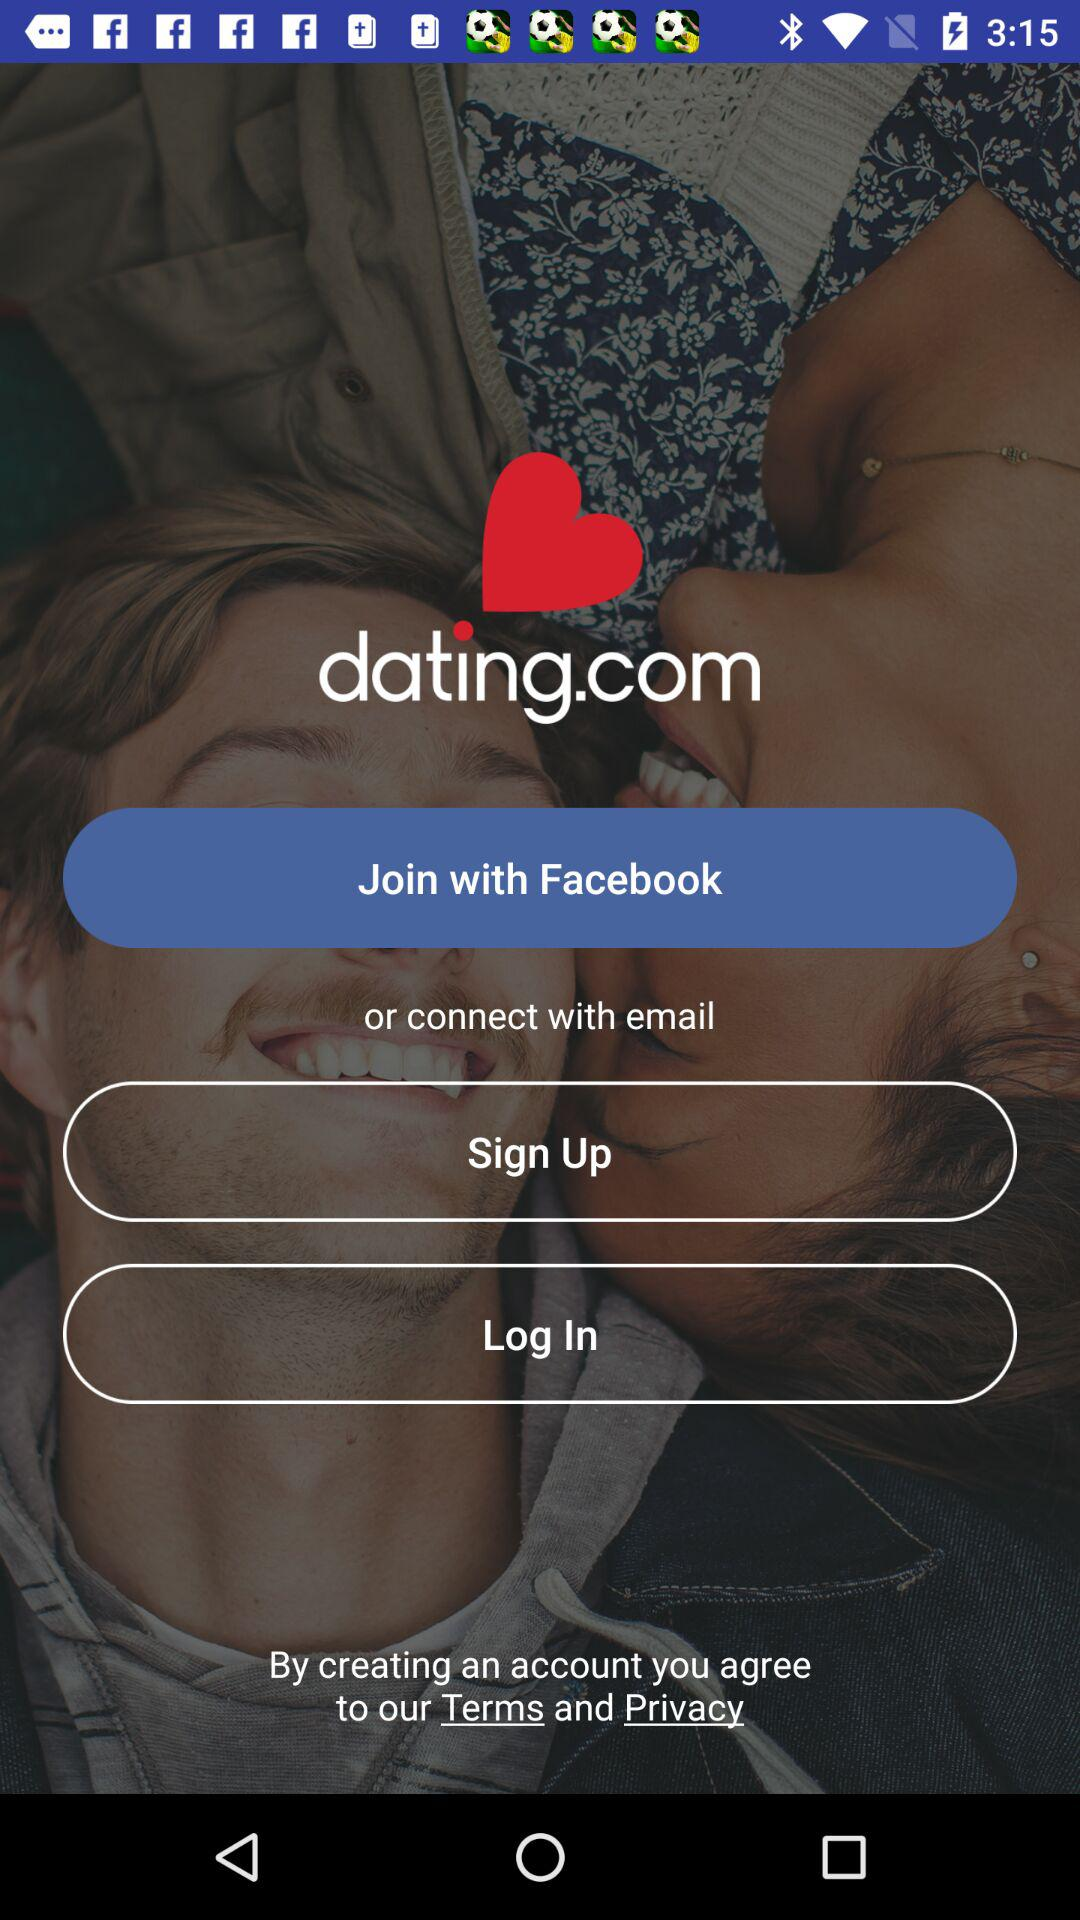What accounts can be used to sign up? The accounts that can be used to sign up are "Facebook" and "email". 